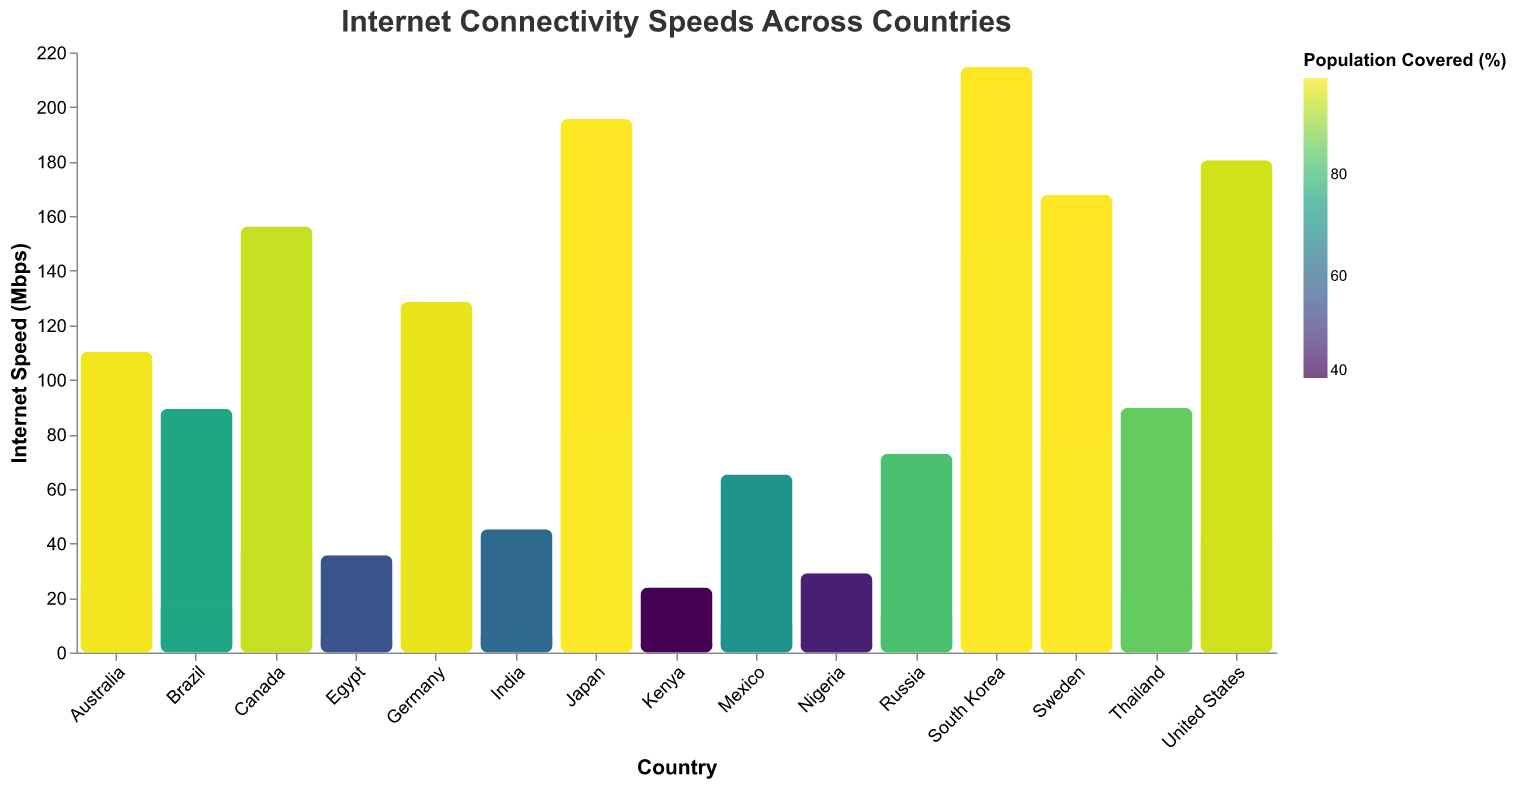What is the title of the plot? The title of the plot is displayed at the top of the figure. It is 'Internet Connectivity Speeds Across Countries'.
Answer: Internet Connectivity Speeds Across Countries Which country has the highest urban internet speed? By inspecting the heights of the bars representing urban internet speeds, South Korea has the highest urban internet speed.
Answer: South Korea What is the urban internet speed in the United States? The height of the bar corresponding to the United States under the 'Urban_Mbps' axis represents its urban internet speed, which is 180.5 Mbps.
Answer: 180.5 Mbps How does the urban internet speed of Germany compare to Japan? Germany's urban internet speed is 128.6 Mbps, while Japan's is 195.6 Mbps. Japan has a higher urban internet speed than Germany.
Answer: Japan has a higher speed What is the rural internet speed in Kenya? The lighter-colored bar for Kenya under the 'Rural_Mbps' axis represents its rural internet speed, which is 5.4 Mbps.
Answer: 5.4 Mbps Which three countries have the smallest disparity between urban and rural internet speeds? The disparities can be calculated as: 
South Korea: (214.7 - 150.2) = 64.5 Mbps,
Japan: (195.6 - 85.3) = 110.3 Mbps,
Sweden: (167.8 - 79.5) = 88.3 Mbps.
The three countries with the smallest disparity are South Korea (64.5 Mbps), Sweden (88.3 Mbps), and Japan (110.3 Mbps).
Answer: South Korea, Sweden, Japan Which country has the lowest rural internet speed? By inspecting the heights of the lighter-colored bars, Nigeria has the lowest rural internet speed at 4.8 Mbps.
Answer: Nigeria What is the population coverage percentage for Brazil? The color intensity of the bar representing Brazil shows its population coverage percentage, which is 75%.
Answer: 75% How much higher is the urban internet speed in Canada compared to Russia? The urban internet speed in Canada is 156.2 Mbps, and in Russia, it is 72.9 Mbps. The difference is 156.2 - 72.9 = 83.3 Mbps.
Answer: 83.3 Mbps Which countries have urban internet speeds above 150 Mbps and population coverage of 99%? By looking at the heights of the bars and the color intensity corresponding to population coverage, the countries are South Korea, Japan, and Sweden.
Answer: South Korea, Japan, Sweden 